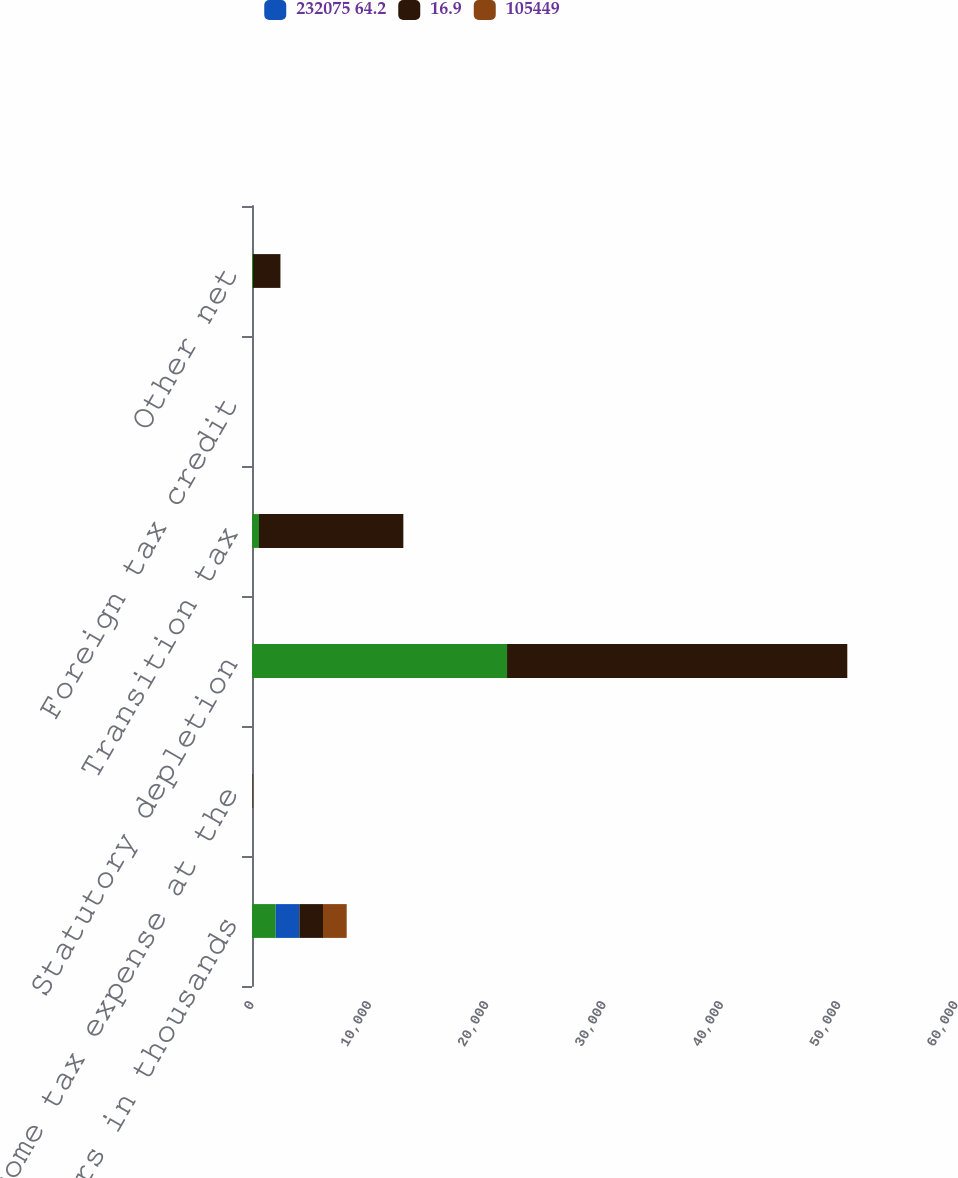Convert chart. <chart><loc_0><loc_0><loc_500><loc_500><stacked_bar_chart><ecel><fcel>dollars in thousands<fcel>Income tax expense at the<fcel>Statutory depletion<fcel>Transition tax<fcel>Foreign tax credit<fcel>Other net<nl><fcel>nan<fcel>2018<fcel>28<fcel>21733<fcel>595<fcel>0<fcel>87<nl><fcel>232075 64.2<fcel>2018<fcel>21<fcel>3.5<fcel>0.1<fcel>0<fcel>0<nl><fcel>16.9<fcel>2017<fcel>28<fcel>28995<fcel>12301<fcel>0<fcel>2337<nl><fcel>105449<fcel>2017<fcel>35<fcel>8<fcel>3.4<fcel>0<fcel>0.6<nl></chart> 